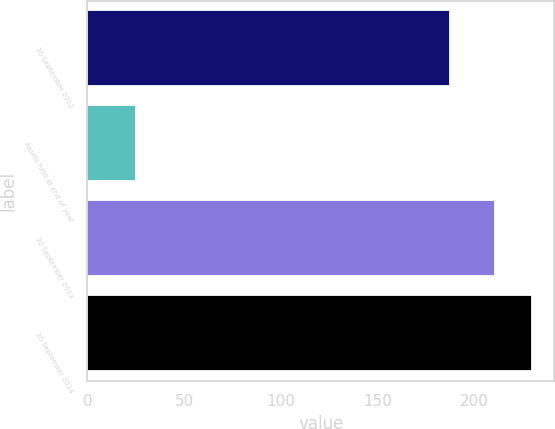Convert chart to OTSL. <chart><loc_0><loc_0><loc_500><loc_500><bar_chart><fcel>30 September 2012<fcel>Assets held at end of year<fcel>30 September 2013<fcel>30 September 2014<nl><fcel>187.2<fcel>25<fcel>210.5<fcel>229.92<nl></chart> 